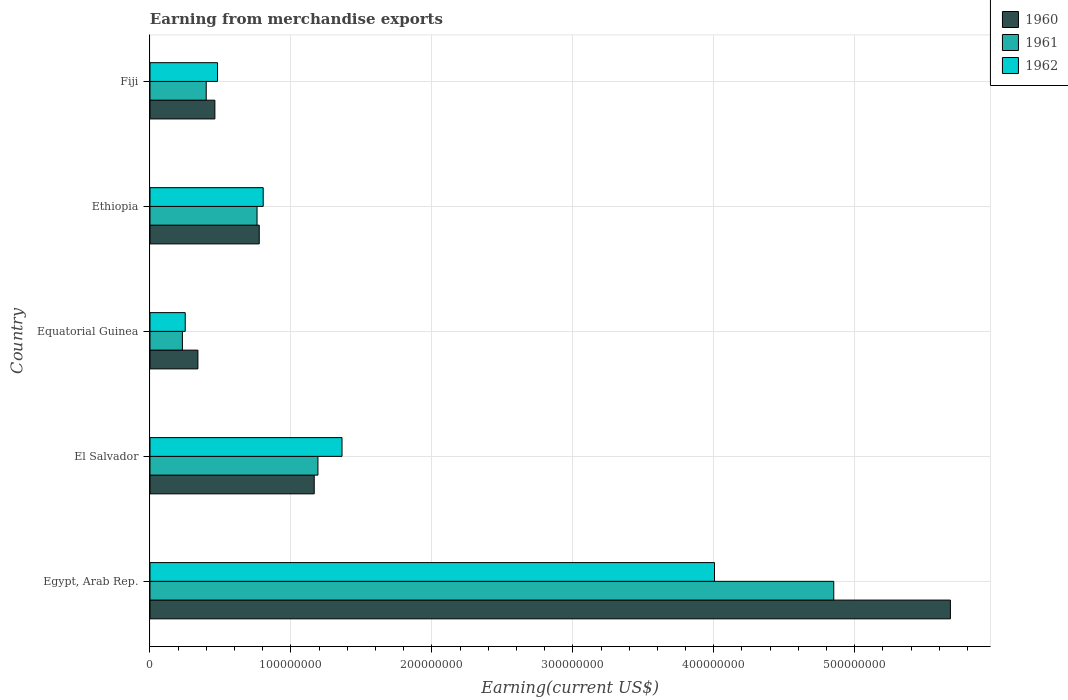How many different coloured bars are there?
Your answer should be very brief. 3. How many groups of bars are there?
Make the answer very short. 5. What is the label of the 4th group of bars from the top?
Your answer should be very brief. El Salvador. In how many cases, is the number of bars for a given country not equal to the number of legend labels?
Give a very brief answer. 0. What is the amount earned from merchandise exports in 1961 in El Salvador?
Keep it short and to the point. 1.19e+08. Across all countries, what is the maximum amount earned from merchandise exports in 1960?
Offer a terse response. 5.68e+08. Across all countries, what is the minimum amount earned from merchandise exports in 1960?
Provide a succinct answer. 3.40e+07. In which country was the amount earned from merchandise exports in 1962 maximum?
Give a very brief answer. Egypt, Arab Rep. In which country was the amount earned from merchandise exports in 1962 minimum?
Keep it short and to the point. Equatorial Guinea. What is the total amount earned from merchandise exports in 1961 in the graph?
Make the answer very short. 7.43e+08. What is the difference between the amount earned from merchandise exports in 1960 in El Salvador and that in Equatorial Guinea?
Keep it short and to the point. 8.25e+07. What is the difference between the amount earned from merchandise exports in 1960 in El Salvador and the amount earned from merchandise exports in 1962 in Fiji?
Offer a very short reply. 6.86e+07. What is the average amount earned from merchandise exports in 1961 per country?
Provide a short and direct response. 1.49e+08. What is the difference between the amount earned from merchandise exports in 1962 and amount earned from merchandise exports in 1961 in El Salvador?
Provide a succinct answer. 1.71e+07. In how many countries, is the amount earned from merchandise exports in 1962 greater than 60000000 US$?
Your response must be concise. 3. What is the ratio of the amount earned from merchandise exports in 1962 in Ethiopia to that in Fiji?
Ensure brevity in your answer.  1.68. What is the difference between the highest and the second highest amount earned from merchandise exports in 1961?
Offer a very short reply. 3.66e+08. What is the difference between the highest and the lowest amount earned from merchandise exports in 1961?
Make the answer very short. 4.62e+08. In how many countries, is the amount earned from merchandise exports in 1960 greater than the average amount earned from merchandise exports in 1960 taken over all countries?
Give a very brief answer. 1. Is the sum of the amount earned from merchandise exports in 1960 in Equatorial Guinea and Ethiopia greater than the maximum amount earned from merchandise exports in 1961 across all countries?
Offer a very short reply. No. What does the 1st bar from the top in Ethiopia represents?
Provide a succinct answer. 1962. How many bars are there?
Your answer should be compact. 15. Are all the bars in the graph horizontal?
Make the answer very short. Yes. What is the difference between two consecutive major ticks on the X-axis?
Your answer should be very brief. 1.00e+08. Does the graph contain grids?
Offer a very short reply. Yes. What is the title of the graph?
Your answer should be very brief. Earning from merchandise exports. What is the label or title of the X-axis?
Ensure brevity in your answer.  Earning(current US$). What is the Earning(current US$) of 1960 in Egypt, Arab Rep.?
Your answer should be very brief. 5.68e+08. What is the Earning(current US$) of 1961 in Egypt, Arab Rep.?
Keep it short and to the point. 4.85e+08. What is the Earning(current US$) in 1962 in Egypt, Arab Rep.?
Your answer should be compact. 4.01e+08. What is the Earning(current US$) in 1960 in El Salvador?
Offer a very short reply. 1.17e+08. What is the Earning(current US$) of 1961 in El Salvador?
Your response must be concise. 1.19e+08. What is the Earning(current US$) of 1962 in El Salvador?
Offer a terse response. 1.36e+08. What is the Earning(current US$) in 1960 in Equatorial Guinea?
Offer a very short reply. 3.40e+07. What is the Earning(current US$) in 1961 in Equatorial Guinea?
Provide a succinct answer. 2.30e+07. What is the Earning(current US$) of 1962 in Equatorial Guinea?
Offer a very short reply. 2.50e+07. What is the Earning(current US$) of 1960 in Ethiopia?
Your answer should be compact. 7.75e+07. What is the Earning(current US$) in 1961 in Ethiopia?
Ensure brevity in your answer.  7.60e+07. What is the Earning(current US$) of 1962 in Ethiopia?
Give a very brief answer. 8.03e+07. What is the Earning(current US$) in 1960 in Fiji?
Offer a terse response. 4.60e+07. What is the Earning(current US$) in 1961 in Fiji?
Your answer should be compact. 3.99e+07. What is the Earning(current US$) in 1962 in Fiji?
Ensure brevity in your answer.  4.79e+07. Across all countries, what is the maximum Earning(current US$) of 1960?
Give a very brief answer. 5.68e+08. Across all countries, what is the maximum Earning(current US$) of 1961?
Give a very brief answer. 4.85e+08. Across all countries, what is the maximum Earning(current US$) in 1962?
Provide a succinct answer. 4.01e+08. Across all countries, what is the minimum Earning(current US$) in 1960?
Provide a succinct answer. 3.40e+07. Across all countries, what is the minimum Earning(current US$) in 1961?
Make the answer very short. 2.30e+07. Across all countries, what is the minimum Earning(current US$) of 1962?
Your answer should be compact. 2.50e+07. What is the total Earning(current US$) of 1960 in the graph?
Keep it short and to the point. 8.42e+08. What is the total Earning(current US$) in 1961 in the graph?
Offer a very short reply. 7.43e+08. What is the total Earning(current US$) in 1962 in the graph?
Your answer should be compact. 6.90e+08. What is the difference between the Earning(current US$) of 1960 in Egypt, Arab Rep. and that in El Salvador?
Give a very brief answer. 4.51e+08. What is the difference between the Earning(current US$) in 1961 in Egypt, Arab Rep. and that in El Salvador?
Provide a short and direct response. 3.66e+08. What is the difference between the Earning(current US$) in 1962 in Egypt, Arab Rep. and that in El Salvador?
Your answer should be very brief. 2.64e+08. What is the difference between the Earning(current US$) in 1960 in Egypt, Arab Rep. and that in Equatorial Guinea?
Give a very brief answer. 5.34e+08. What is the difference between the Earning(current US$) in 1961 in Egypt, Arab Rep. and that in Equatorial Guinea?
Offer a terse response. 4.62e+08. What is the difference between the Earning(current US$) of 1962 in Egypt, Arab Rep. and that in Equatorial Guinea?
Your answer should be compact. 3.76e+08. What is the difference between the Earning(current US$) of 1960 in Egypt, Arab Rep. and that in Ethiopia?
Your response must be concise. 4.90e+08. What is the difference between the Earning(current US$) of 1961 in Egypt, Arab Rep. and that in Ethiopia?
Offer a very short reply. 4.09e+08. What is the difference between the Earning(current US$) in 1962 in Egypt, Arab Rep. and that in Ethiopia?
Offer a terse response. 3.20e+08. What is the difference between the Earning(current US$) in 1960 in Egypt, Arab Rep. and that in Fiji?
Offer a terse response. 5.22e+08. What is the difference between the Earning(current US$) in 1961 in Egypt, Arab Rep. and that in Fiji?
Offer a very short reply. 4.45e+08. What is the difference between the Earning(current US$) of 1962 in Egypt, Arab Rep. and that in Fiji?
Your answer should be compact. 3.53e+08. What is the difference between the Earning(current US$) of 1960 in El Salvador and that in Equatorial Guinea?
Offer a very short reply. 8.25e+07. What is the difference between the Earning(current US$) in 1961 in El Salvador and that in Equatorial Guinea?
Your answer should be compact. 9.62e+07. What is the difference between the Earning(current US$) in 1962 in El Salvador and that in Equatorial Guinea?
Make the answer very short. 1.11e+08. What is the difference between the Earning(current US$) of 1960 in El Salvador and that in Ethiopia?
Provide a short and direct response. 3.90e+07. What is the difference between the Earning(current US$) in 1961 in El Salvador and that in Ethiopia?
Offer a very short reply. 4.32e+07. What is the difference between the Earning(current US$) of 1962 in El Salvador and that in Ethiopia?
Your response must be concise. 5.59e+07. What is the difference between the Earning(current US$) of 1960 in El Salvador and that in Fiji?
Your answer should be very brief. 7.05e+07. What is the difference between the Earning(current US$) in 1961 in El Salvador and that in Fiji?
Offer a terse response. 7.93e+07. What is the difference between the Earning(current US$) in 1962 in El Salvador and that in Fiji?
Your answer should be very brief. 8.83e+07. What is the difference between the Earning(current US$) in 1960 in Equatorial Guinea and that in Ethiopia?
Provide a succinct answer. -4.35e+07. What is the difference between the Earning(current US$) of 1961 in Equatorial Guinea and that in Ethiopia?
Ensure brevity in your answer.  -5.30e+07. What is the difference between the Earning(current US$) of 1962 in Equatorial Guinea and that in Ethiopia?
Your response must be concise. -5.53e+07. What is the difference between the Earning(current US$) of 1960 in Equatorial Guinea and that in Fiji?
Your answer should be compact. -1.20e+07. What is the difference between the Earning(current US$) of 1961 in Equatorial Guinea and that in Fiji?
Give a very brief answer. -1.69e+07. What is the difference between the Earning(current US$) in 1962 in Equatorial Guinea and that in Fiji?
Your answer should be compact. -2.29e+07. What is the difference between the Earning(current US$) of 1960 in Ethiopia and that in Fiji?
Offer a terse response. 3.15e+07. What is the difference between the Earning(current US$) in 1961 in Ethiopia and that in Fiji?
Keep it short and to the point. 3.61e+07. What is the difference between the Earning(current US$) in 1962 in Ethiopia and that in Fiji?
Give a very brief answer. 3.24e+07. What is the difference between the Earning(current US$) in 1960 in Egypt, Arab Rep. and the Earning(current US$) in 1961 in El Salvador?
Offer a terse response. 4.49e+08. What is the difference between the Earning(current US$) in 1960 in Egypt, Arab Rep. and the Earning(current US$) in 1962 in El Salvador?
Keep it short and to the point. 4.32e+08. What is the difference between the Earning(current US$) of 1961 in Egypt, Arab Rep. and the Earning(current US$) of 1962 in El Salvador?
Keep it short and to the point. 3.49e+08. What is the difference between the Earning(current US$) in 1960 in Egypt, Arab Rep. and the Earning(current US$) in 1961 in Equatorial Guinea?
Provide a succinct answer. 5.45e+08. What is the difference between the Earning(current US$) of 1960 in Egypt, Arab Rep. and the Earning(current US$) of 1962 in Equatorial Guinea?
Your response must be concise. 5.43e+08. What is the difference between the Earning(current US$) in 1961 in Egypt, Arab Rep. and the Earning(current US$) in 1962 in Equatorial Guinea?
Provide a succinct answer. 4.60e+08. What is the difference between the Earning(current US$) in 1960 in Egypt, Arab Rep. and the Earning(current US$) in 1961 in Ethiopia?
Provide a short and direct response. 4.92e+08. What is the difference between the Earning(current US$) of 1960 in Egypt, Arab Rep. and the Earning(current US$) of 1962 in Ethiopia?
Offer a terse response. 4.88e+08. What is the difference between the Earning(current US$) of 1961 in Egypt, Arab Rep. and the Earning(current US$) of 1962 in Ethiopia?
Provide a succinct answer. 4.05e+08. What is the difference between the Earning(current US$) of 1960 in Egypt, Arab Rep. and the Earning(current US$) of 1961 in Fiji?
Make the answer very short. 5.28e+08. What is the difference between the Earning(current US$) of 1960 in Egypt, Arab Rep. and the Earning(current US$) of 1962 in Fiji?
Offer a very short reply. 5.20e+08. What is the difference between the Earning(current US$) of 1961 in Egypt, Arab Rep. and the Earning(current US$) of 1962 in Fiji?
Ensure brevity in your answer.  4.37e+08. What is the difference between the Earning(current US$) in 1960 in El Salvador and the Earning(current US$) in 1961 in Equatorial Guinea?
Your response must be concise. 9.35e+07. What is the difference between the Earning(current US$) in 1960 in El Salvador and the Earning(current US$) in 1962 in Equatorial Guinea?
Provide a short and direct response. 9.15e+07. What is the difference between the Earning(current US$) in 1961 in El Salvador and the Earning(current US$) in 1962 in Equatorial Guinea?
Your answer should be compact. 9.42e+07. What is the difference between the Earning(current US$) of 1960 in El Salvador and the Earning(current US$) of 1961 in Ethiopia?
Offer a terse response. 4.06e+07. What is the difference between the Earning(current US$) in 1960 in El Salvador and the Earning(current US$) in 1962 in Ethiopia?
Your answer should be very brief. 3.62e+07. What is the difference between the Earning(current US$) of 1961 in El Salvador and the Earning(current US$) of 1962 in Ethiopia?
Keep it short and to the point. 3.88e+07. What is the difference between the Earning(current US$) of 1960 in El Salvador and the Earning(current US$) of 1961 in Fiji?
Give a very brief answer. 7.66e+07. What is the difference between the Earning(current US$) of 1960 in El Salvador and the Earning(current US$) of 1962 in Fiji?
Your response must be concise. 6.86e+07. What is the difference between the Earning(current US$) of 1961 in El Salvador and the Earning(current US$) of 1962 in Fiji?
Offer a very short reply. 7.12e+07. What is the difference between the Earning(current US$) of 1960 in Equatorial Guinea and the Earning(current US$) of 1961 in Ethiopia?
Keep it short and to the point. -4.20e+07. What is the difference between the Earning(current US$) of 1960 in Equatorial Guinea and the Earning(current US$) of 1962 in Ethiopia?
Your response must be concise. -4.63e+07. What is the difference between the Earning(current US$) of 1961 in Equatorial Guinea and the Earning(current US$) of 1962 in Ethiopia?
Your response must be concise. -5.73e+07. What is the difference between the Earning(current US$) of 1960 in Equatorial Guinea and the Earning(current US$) of 1961 in Fiji?
Offer a terse response. -5.90e+06. What is the difference between the Earning(current US$) of 1960 in Equatorial Guinea and the Earning(current US$) of 1962 in Fiji?
Your answer should be compact. -1.39e+07. What is the difference between the Earning(current US$) in 1961 in Equatorial Guinea and the Earning(current US$) in 1962 in Fiji?
Provide a succinct answer. -2.49e+07. What is the difference between the Earning(current US$) in 1960 in Ethiopia and the Earning(current US$) in 1961 in Fiji?
Offer a terse response. 3.76e+07. What is the difference between the Earning(current US$) of 1960 in Ethiopia and the Earning(current US$) of 1962 in Fiji?
Offer a very short reply. 2.96e+07. What is the difference between the Earning(current US$) of 1961 in Ethiopia and the Earning(current US$) of 1962 in Fiji?
Offer a very short reply. 2.80e+07. What is the average Earning(current US$) of 1960 per country?
Your answer should be very brief. 1.68e+08. What is the average Earning(current US$) in 1961 per country?
Your answer should be compact. 1.49e+08. What is the average Earning(current US$) in 1962 per country?
Provide a short and direct response. 1.38e+08. What is the difference between the Earning(current US$) of 1960 and Earning(current US$) of 1961 in Egypt, Arab Rep.?
Offer a terse response. 8.28e+07. What is the difference between the Earning(current US$) in 1960 and Earning(current US$) in 1962 in Egypt, Arab Rep.?
Provide a short and direct response. 1.67e+08. What is the difference between the Earning(current US$) in 1961 and Earning(current US$) in 1962 in Egypt, Arab Rep.?
Your answer should be very brief. 8.46e+07. What is the difference between the Earning(current US$) of 1960 and Earning(current US$) of 1961 in El Salvador?
Your answer should be compact. -2.64e+06. What is the difference between the Earning(current US$) of 1960 and Earning(current US$) of 1962 in El Salvador?
Offer a very short reply. -1.97e+07. What is the difference between the Earning(current US$) of 1961 and Earning(current US$) of 1962 in El Salvador?
Ensure brevity in your answer.  -1.71e+07. What is the difference between the Earning(current US$) of 1960 and Earning(current US$) of 1961 in Equatorial Guinea?
Ensure brevity in your answer.  1.10e+07. What is the difference between the Earning(current US$) of 1960 and Earning(current US$) of 1962 in Equatorial Guinea?
Provide a short and direct response. 9.00e+06. What is the difference between the Earning(current US$) in 1961 and Earning(current US$) in 1962 in Equatorial Guinea?
Your answer should be very brief. -2.00e+06. What is the difference between the Earning(current US$) of 1960 and Earning(current US$) of 1961 in Ethiopia?
Offer a terse response. 1.57e+06. What is the difference between the Earning(current US$) in 1960 and Earning(current US$) in 1962 in Ethiopia?
Provide a succinct answer. -2.80e+06. What is the difference between the Earning(current US$) in 1961 and Earning(current US$) in 1962 in Ethiopia?
Give a very brief answer. -4.37e+06. What is the difference between the Earning(current US$) in 1960 and Earning(current US$) in 1961 in Fiji?
Make the answer very short. 6.14e+06. What is the difference between the Earning(current US$) in 1960 and Earning(current US$) in 1962 in Fiji?
Make the answer very short. -1.89e+06. What is the difference between the Earning(current US$) in 1961 and Earning(current US$) in 1962 in Fiji?
Your response must be concise. -8.02e+06. What is the ratio of the Earning(current US$) of 1960 in Egypt, Arab Rep. to that in El Salvador?
Your response must be concise. 4.87. What is the ratio of the Earning(current US$) in 1961 in Egypt, Arab Rep. to that in El Salvador?
Ensure brevity in your answer.  4.07. What is the ratio of the Earning(current US$) of 1962 in Egypt, Arab Rep. to that in El Salvador?
Provide a short and direct response. 2.94. What is the ratio of the Earning(current US$) of 1960 in Egypt, Arab Rep. to that in Equatorial Guinea?
Keep it short and to the point. 16.7. What is the ratio of the Earning(current US$) of 1961 in Egypt, Arab Rep. to that in Equatorial Guinea?
Ensure brevity in your answer.  21.09. What is the ratio of the Earning(current US$) in 1962 in Egypt, Arab Rep. to that in Equatorial Guinea?
Make the answer very short. 16.02. What is the ratio of the Earning(current US$) in 1960 in Egypt, Arab Rep. to that in Ethiopia?
Ensure brevity in your answer.  7.33. What is the ratio of the Earning(current US$) of 1961 in Egypt, Arab Rep. to that in Ethiopia?
Provide a short and direct response. 6.39. What is the ratio of the Earning(current US$) in 1962 in Egypt, Arab Rep. to that in Ethiopia?
Offer a very short reply. 4.99. What is the ratio of the Earning(current US$) in 1960 in Egypt, Arab Rep. to that in Fiji?
Keep it short and to the point. 12.34. What is the ratio of the Earning(current US$) in 1961 in Egypt, Arab Rep. to that in Fiji?
Offer a terse response. 12.16. What is the ratio of the Earning(current US$) of 1962 in Egypt, Arab Rep. to that in Fiji?
Your answer should be very brief. 8.36. What is the ratio of the Earning(current US$) of 1960 in El Salvador to that in Equatorial Guinea?
Provide a short and direct response. 3.43. What is the ratio of the Earning(current US$) in 1961 in El Salvador to that in Equatorial Guinea?
Provide a succinct answer. 5.18. What is the ratio of the Earning(current US$) in 1962 in El Salvador to that in Equatorial Guinea?
Your response must be concise. 5.45. What is the ratio of the Earning(current US$) of 1960 in El Salvador to that in Ethiopia?
Provide a short and direct response. 1.5. What is the ratio of the Earning(current US$) of 1961 in El Salvador to that in Ethiopia?
Your response must be concise. 1.57. What is the ratio of the Earning(current US$) in 1962 in El Salvador to that in Ethiopia?
Provide a short and direct response. 1.7. What is the ratio of the Earning(current US$) in 1960 in El Salvador to that in Fiji?
Provide a succinct answer. 2.53. What is the ratio of the Earning(current US$) in 1961 in El Salvador to that in Fiji?
Provide a succinct answer. 2.99. What is the ratio of the Earning(current US$) of 1962 in El Salvador to that in Fiji?
Keep it short and to the point. 2.84. What is the ratio of the Earning(current US$) of 1960 in Equatorial Guinea to that in Ethiopia?
Your response must be concise. 0.44. What is the ratio of the Earning(current US$) of 1961 in Equatorial Guinea to that in Ethiopia?
Keep it short and to the point. 0.3. What is the ratio of the Earning(current US$) of 1962 in Equatorial Guinea to that in Ethiopia?
Give a very brief answer. 0.31. What is the ratio of the Earning(current US$) of 1960 in Equatorial Guinea to that in Fiji?
Offer a terse response. 0.74. What is the ratio of the Earning(current US$) of 1961 in Equatorial Guinea to that in Fiji?
Your response must be concise. 0.58. What is the ratio of the Earning(current US$) of 1962 in Equatorial Guinea to that in Fiji?
Provide a succinct answer. 0.52. What is the ratio of the Earning(current US$) of 1960 in Ethiopia to that in Fiji?
Keep it short and to the point. 1.68. What is the ratio of the Earning(current US$) of 1961 in Ethiopia to that in Fiji?
Your answer should be compact. 1.9. What is the ratio of the Earning(current US$) of 1962 in Ethiopia to that in Fiji?
Offer a terse response. 1.68. What is the difference between the highest and the second highest Earning(current US$) in 1960?
Your answer should be very brief. 4.51e+08. What is the difference between the highest and the second highest Earning(current US$) in 1961?
Offer a terse response. 3.66e+08. What is the difference between the highest and the second highest Earning(current US$) in 1962?
Provide a short and direct response. 2.64e+08. What is the difference between the highest and the lowest Earning(current US$) in 1960?
Make the answer very short. 5.34e+08. What is the difference between the highest and the lowest Earning(current US$) in 1961?
Make the answer very short. 4.62e+08. What is the difference between the highest and the lowest Earning(current US$) of 1962?
Offer a terse response. 3.76e+08. 